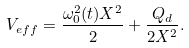Convert formula to latex. <formula><loc_0><loc_0><loc_500><loc_500>V _ { e f f } = \frac { \omega _ { 0 } ^ { 2 } ( t ) X ^ { 2 } } { 2 } + \frac { Q _ { d } } { 2 X ^ { 2 } } .</formula> 